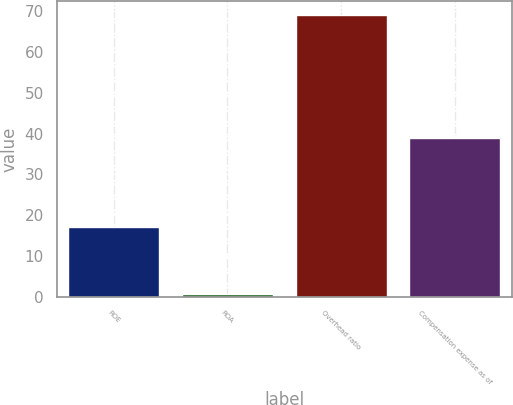Convert chart to OTSL. <chart><loc_0><loc_0><loc_500><loc_500><bar_chart><fcel>ROE<fcel>ROA<fcel>Overhead ratio<fcel>Compensation expense as of<nl><fcel>17<fcel>0.62<fcel>69<fcel>39<nl></chart> 